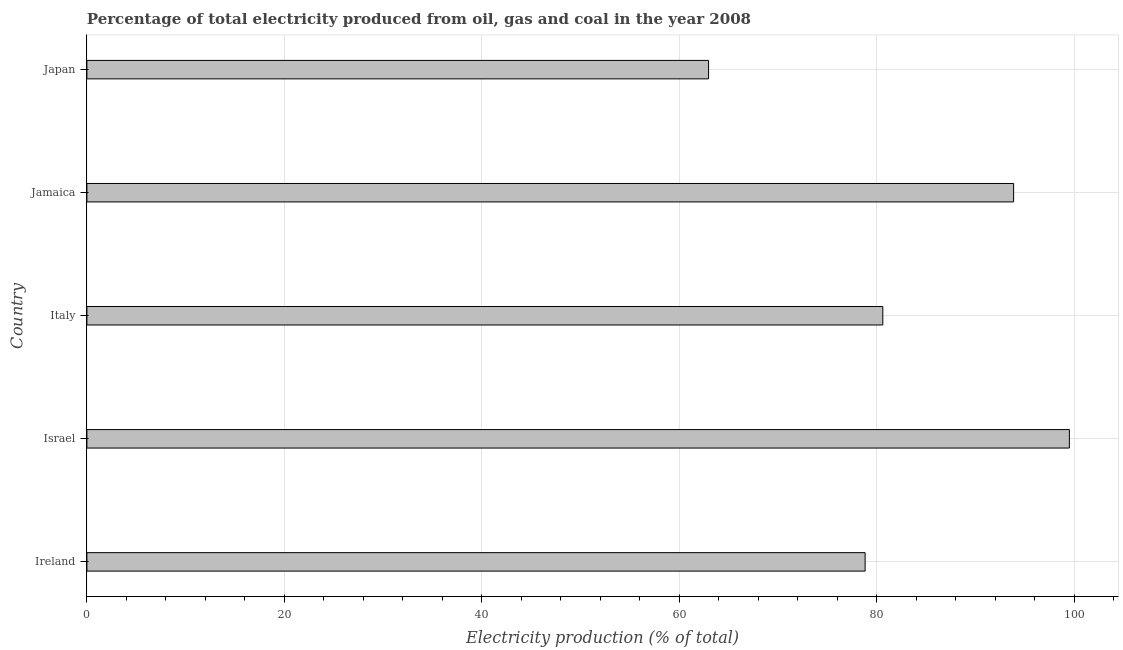Does the graph contain any zero values?
Your response must be concise. No. What is the title of the graph?
Your answer should be very brief. Percentage of total electricity produced from oil, gas and coal in the year 2008. What is the label or title of the X-axis?
Your answer should be compact. Electricity production (% of total). What is the label or title of the Y-axis?
Your response must be concise. Country. What is the electricity production in Ireland?
Give a very brief answer. 78.82. Across all countries, what is the maximum electricity production?
Make the answer very short. 99.51. Across all countries, what is the minimum electricity production?
Offer a terse response. 62.97. What is the sum of the electricity production?
Offer a terse response. 415.77. What is the difference between the electricity production in Jamaica and Japan?
Your answer should be compact. 30.89. What is the average electricity production per country?
Ensure brevity in your answer.  83.15. What is the median electricity production?
Offer a terse response. 80.61. In how many countries, is the electricity production greater than 20 %?
Provide a succinct answer. 5. What is the ratio of the electricity production in Israel to that in Japan?
Offer a terse response. 1.58. Is the electricity production in Ireland less than that in Japan?
Offer a terse response. No. What is the difference between the highest and the second highest electricity production?
Your answer should be very brief. 5.65. What is the difference between the highest and the lowest electricity production?
Give a very brief answer. 36.54. How many bars are there?
Offer a very short reply. 5. Are all the bars in the graph horizontal?
Your response must be concise. Yes. What is the difference between two consecutive major ticks on the X-axis?
Provide a succinct answer. 20. Are the values on the major ticks of X-axis written in scientific E-notation?
Your answer should be very brief. No. What is the Electricity production (% of total) of Ireland?
Your answer should be very brief. 78.82. What is the Electricity production (% of total) in Israel?
Provide a succinct answer. 99.51. What is the Electricity production (% of total) in Italy?
Keep it short and to the point. 80.61. What is the Electricity production (% of total) in Jamaica?
Offer a terse response. 93.86. What is the Electricity production (% of total) in Japan?
Your response must be concise. 62.97. What is the difference between the Electricity production (% of total) in Ireland and Israel?
Ensure brevity in your answer.  -20.69. What is the difference between the Electricity production (% of total) in Ireland and Italy?
Your answer should be very brief. -1.79. What is the difference between the Electricity production (% of total) in Ireland and Jamaica?
Keep it short and to the point. -15.04. What is the difference between the Electricity production (% of total) in Ireland and Japan?
Offer a very short reply. 15.86. What is the difference between the Electricity production (% of total) in Israel and Italy?
Keep it short and to the point. 18.89. What is the difference between the Electricity production (% of total) in Israel and Jamaica?
Keep it short and to the point. 5.65. What is the difference between the Electricity production (% of total) in Israel and Japan?
Offer a very short reply. 36.54. What is the difference between the Electricity production (% of total) in Italy and Jamaica?
Ensure brevity in your answer.  -13.25. What is the difference between the Electricity production (% of total) in Italy and Japan?
Make the answer very short. 17.65. What is the difference between the Electricity production (% of total) in Jamaica and Japan?
Offer a very short reply. 30.89. What is the ratio of the Electricity production (% of total) in Ireland to that in Israel?
Offer a very short reply. 0.79. What is the ratio of the Electricity production (% of total) in Ireland to that in Jamaica?
Give a very brief answer. 0.84. What is the ratio of the Electricity production (% of total) in Ireland to that in Japan?
Ensure brevity in your answer.  1.25. What is the ratio of the Electricity production (% of total) in Israel to that in Italy?
Your answer should be compact. 1.23. What is the ratio of the Electricity production (% of total) in Israel to that in Jamaica?
Offer a very short reply. 1.06. What is the ratio of the Electricity production (% of total) in Israel to that in Japan?
Ensure brevity in your answer.  1.58. What is the ratio of the Electricity production (% of total) in Italy to that in Jamaica?
Keep it short and to the point. 0.86. What is the ratio of the Electricity production (% of total) in Italy to that in Japan?
Keep it short and to the point. 1.28. What is the ratio of the Electricity production (% of total) in Jamaica to that in Japan?
Make the answer very short. 1.49. 